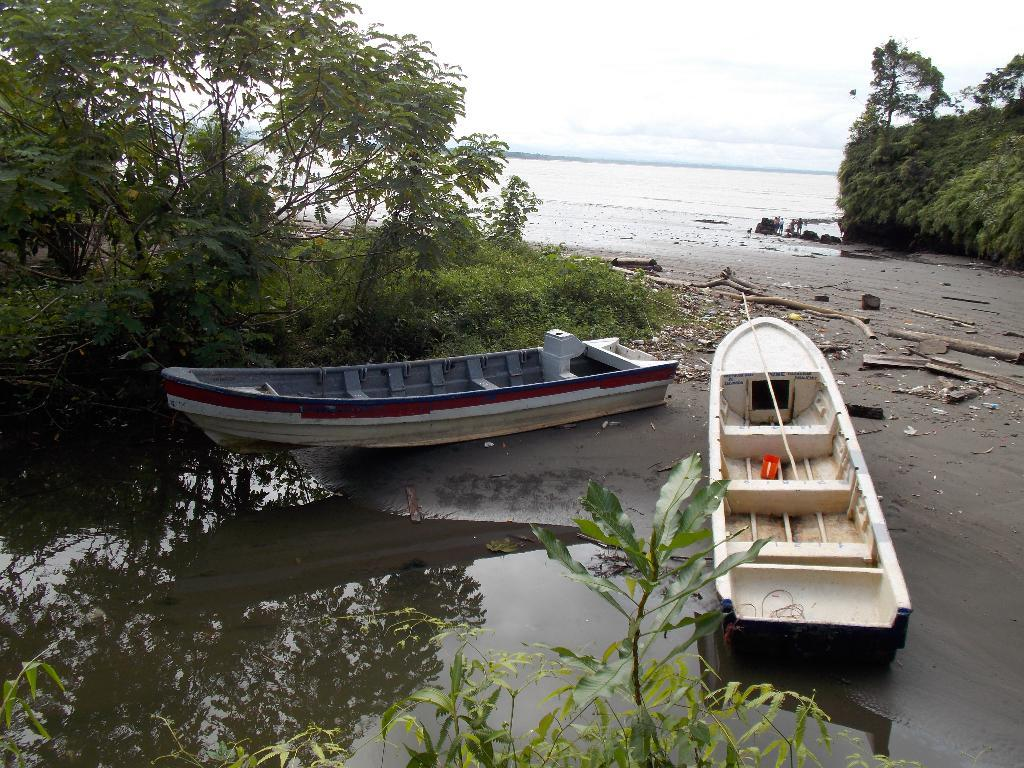What is the primary element visible in the image? There is water in the image. What type of vegetation can be seen in the image? There are trees in the image. What type of vehicles are present in the image? There are boats in the image. What can be seen in the background of the image? There is a group of people in the background of the image. What material are the barks made of in the image? There are wooden barks in the image. How does the porter help the head run in the image? There is no porter or head present in the image, and therefore no such activity can be observed. 